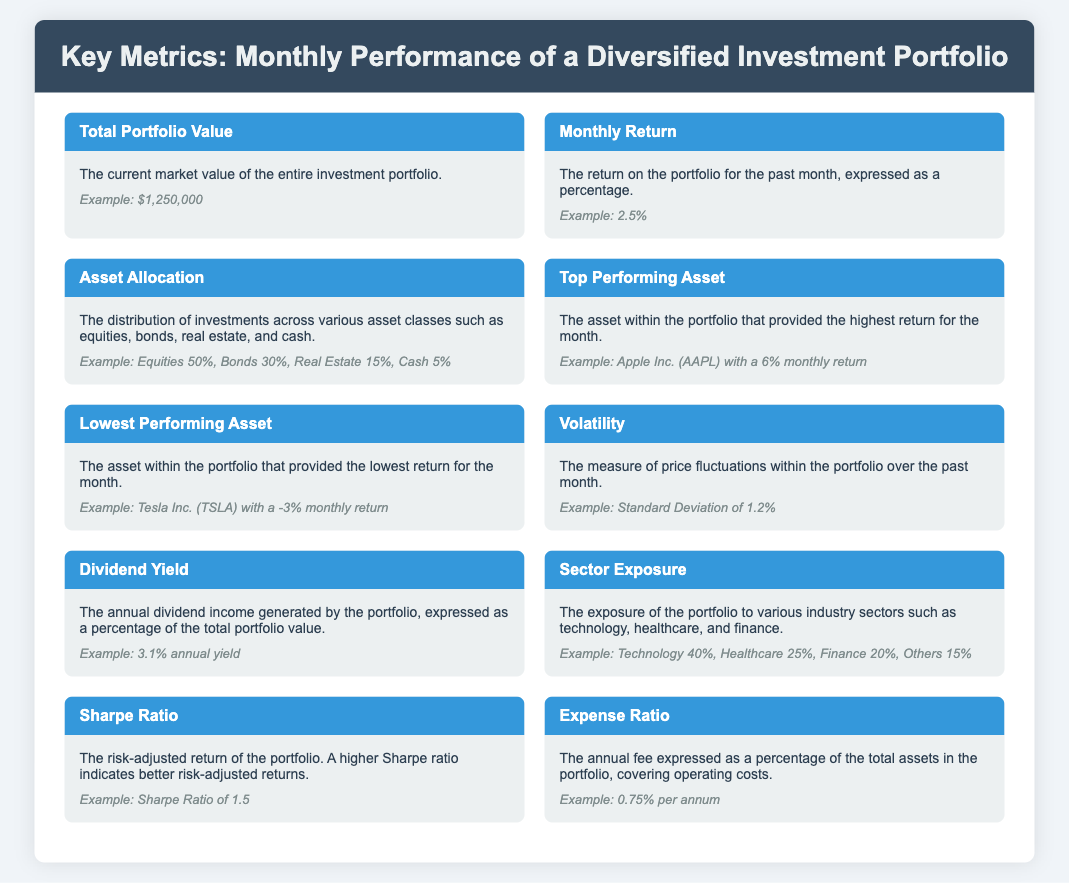What is the total portfolio value? The total portfolio value is the current market value of the entire investment portfolio, which is illustrated in the example.
Answer: $1,250,000 What was the monthly return for the portfolio? The monthly return is expressed as a percentage for the past month, as shown in the document.
Answer: 2.5% What percentage of the portfolio is allocated to bonds? The asset allocation describes the distribution of investments, highlighting specific percentages for each asset class.
Answer: 30% Which asset had the highest return this month? The top-performing asset is identified with its name and the return percentage for the month.
Answer: Apple Inc. (AAPL) What is the standard deviation value for volatility? Volatility refers to the measure of price fluctuations, and the specific value is provided in the example.
Answer: 1.2% What is the annual dividend yield of the portfolio? The dividend yield is shown as a percentage, indicating how much annual income is generated from dividends.
Answer: 3.1% annual yield What is the expense ratio of the portfolio? The expense ratio represents the annual fee expressed as a percentage, a critical metric for portfolio cost.
Answer: 0.75% per annum Which sector has the highest exposure in the portfolio? Sector exposure details the allocation across different sectors with key percentages, allowing for identification of the most exposed sector.
Answer: Technology 40% What does a higher Sharpe ratio indicate? The Sharpe ratio assesses risk-adjusted return, and its significance is clarified in the document.
Answer: Better risk-adjusted returns 